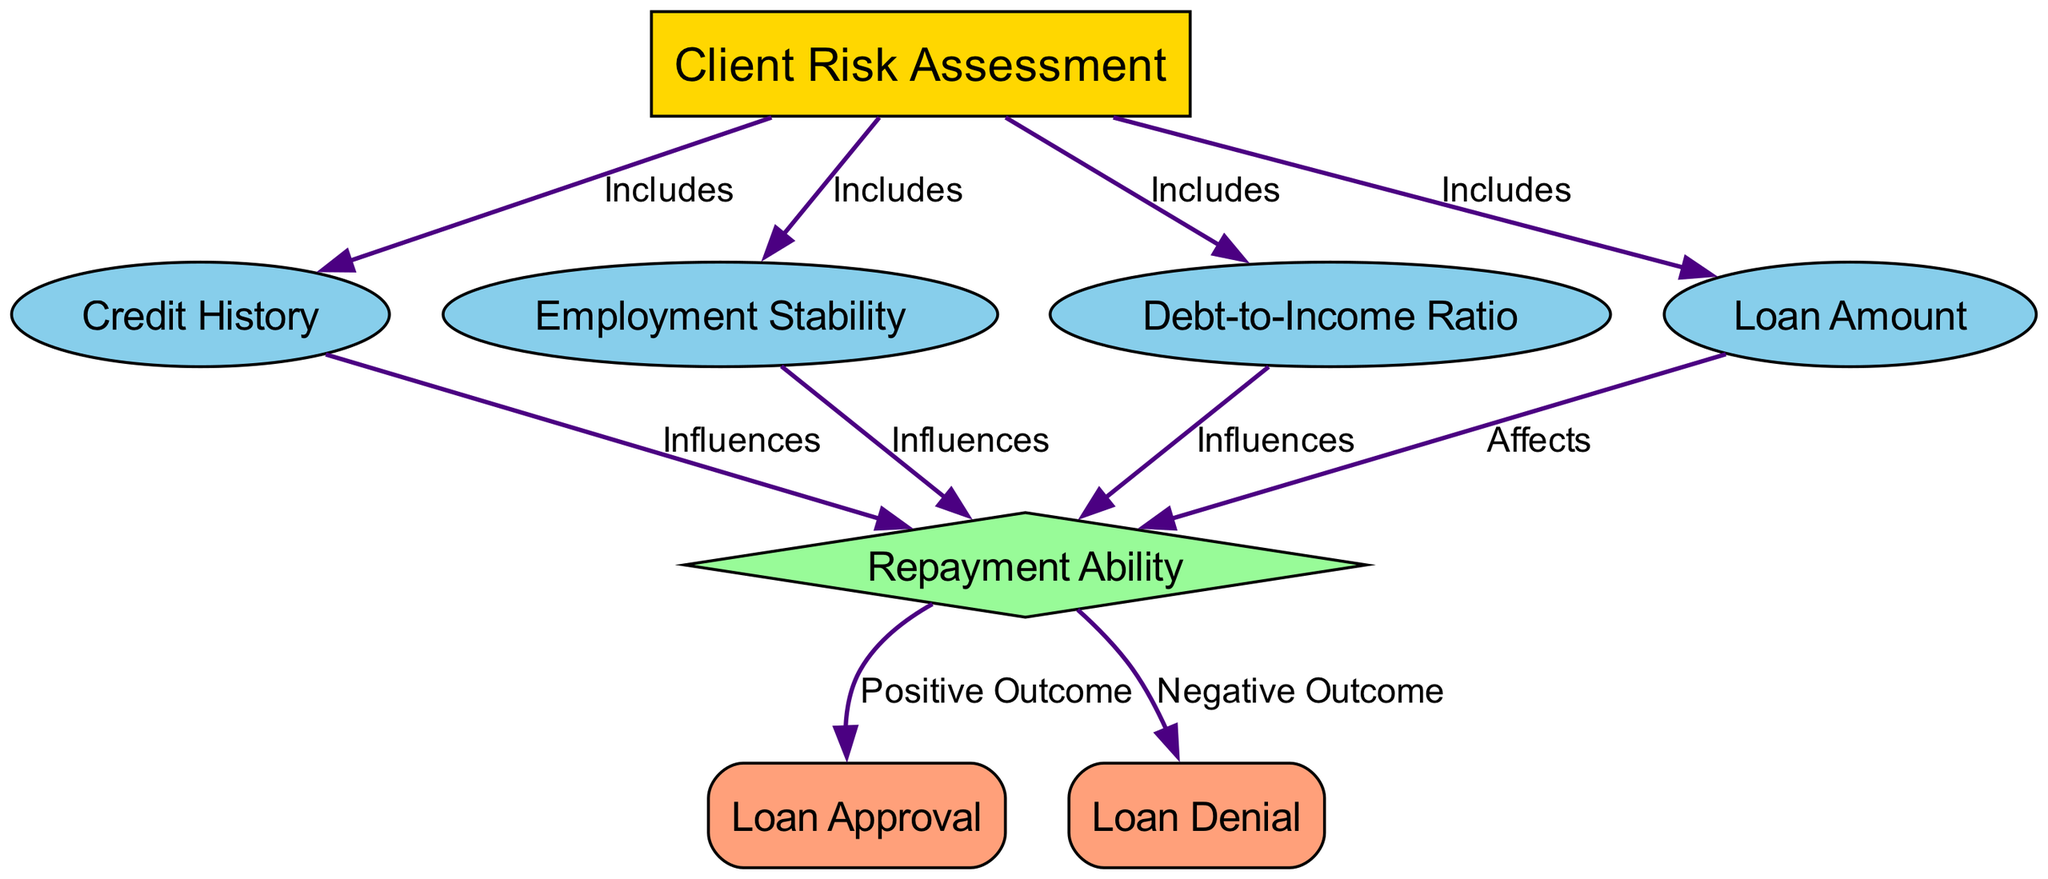what is the main topic of the diagram? The main topic is indicated by the first node labeled "Client Risk Assessment." This node is at the top of the diagram and serves as the overall subject of the relationships depicted.
Answer: Client Risk Assessment how many indicators are included in the diagram? There are four indicators listed in the diagram: "Credit History," "Employment Stability," "Debt-to-Income Ratio," and "Loan Amount." These are specifically identified in the nodes categorized as indicators. Counting these nodes gives a total of four.
Answer: 4 which node influences the repayment ability? The diagram shows that the nodes "Credit History," "Employment Stability," "Debt-to-Income Ratio," and "Loan Amount" all influence the "Repayment Ability." Among these, "Credit History" is the first listed indicator that influences this decision.
Answer: Credit History what is the outcome if the repayment ability is positive? According to the diagram, a positive outcome from "Repayment Ability" leads to "Loan Approval." The edge labeled "Positive Outcome" from "Repayment Ability" flows into "Loan Approval," indicating this relationship.
Answer: Loan Approval which node affects repayment ability the most? The diagram does not provide a metric to measure 'most' directly, but all indicator nodes influence "Repayment Ability." However, "Debt-to-Income Ratio" is critical as it quantifies financial leverage, and its effect is often considered significant in risk assessments.
Answer: Debt-to-Income Ratio what type of edges connect the indicators to repayment ability? The edges connecting the indicators to "Repayment Ability" are labeled "Influences." Each indicator node has a directed edge leading to "Repayment Ability" and is specified to show this type of relationship.
Answer: Influences which outcome is chosen if the repayment ability is negative? If the "Repayment Ability" is negative, the outcome would be "Loan Denial." The edge labeled "Negative Outcome" indicates that when repayment ability does not meet criteria, the loan is not approved.
Answer: Loan Denial how does loan amount relate to repayment ability? The diagram states that "Loan Amount" affects "Repayment Ability." This relationship is indicated by the edge labeled "Affects" which shows the direct impact of loan amount on an individual's ability to repay.
Answer: Affects 